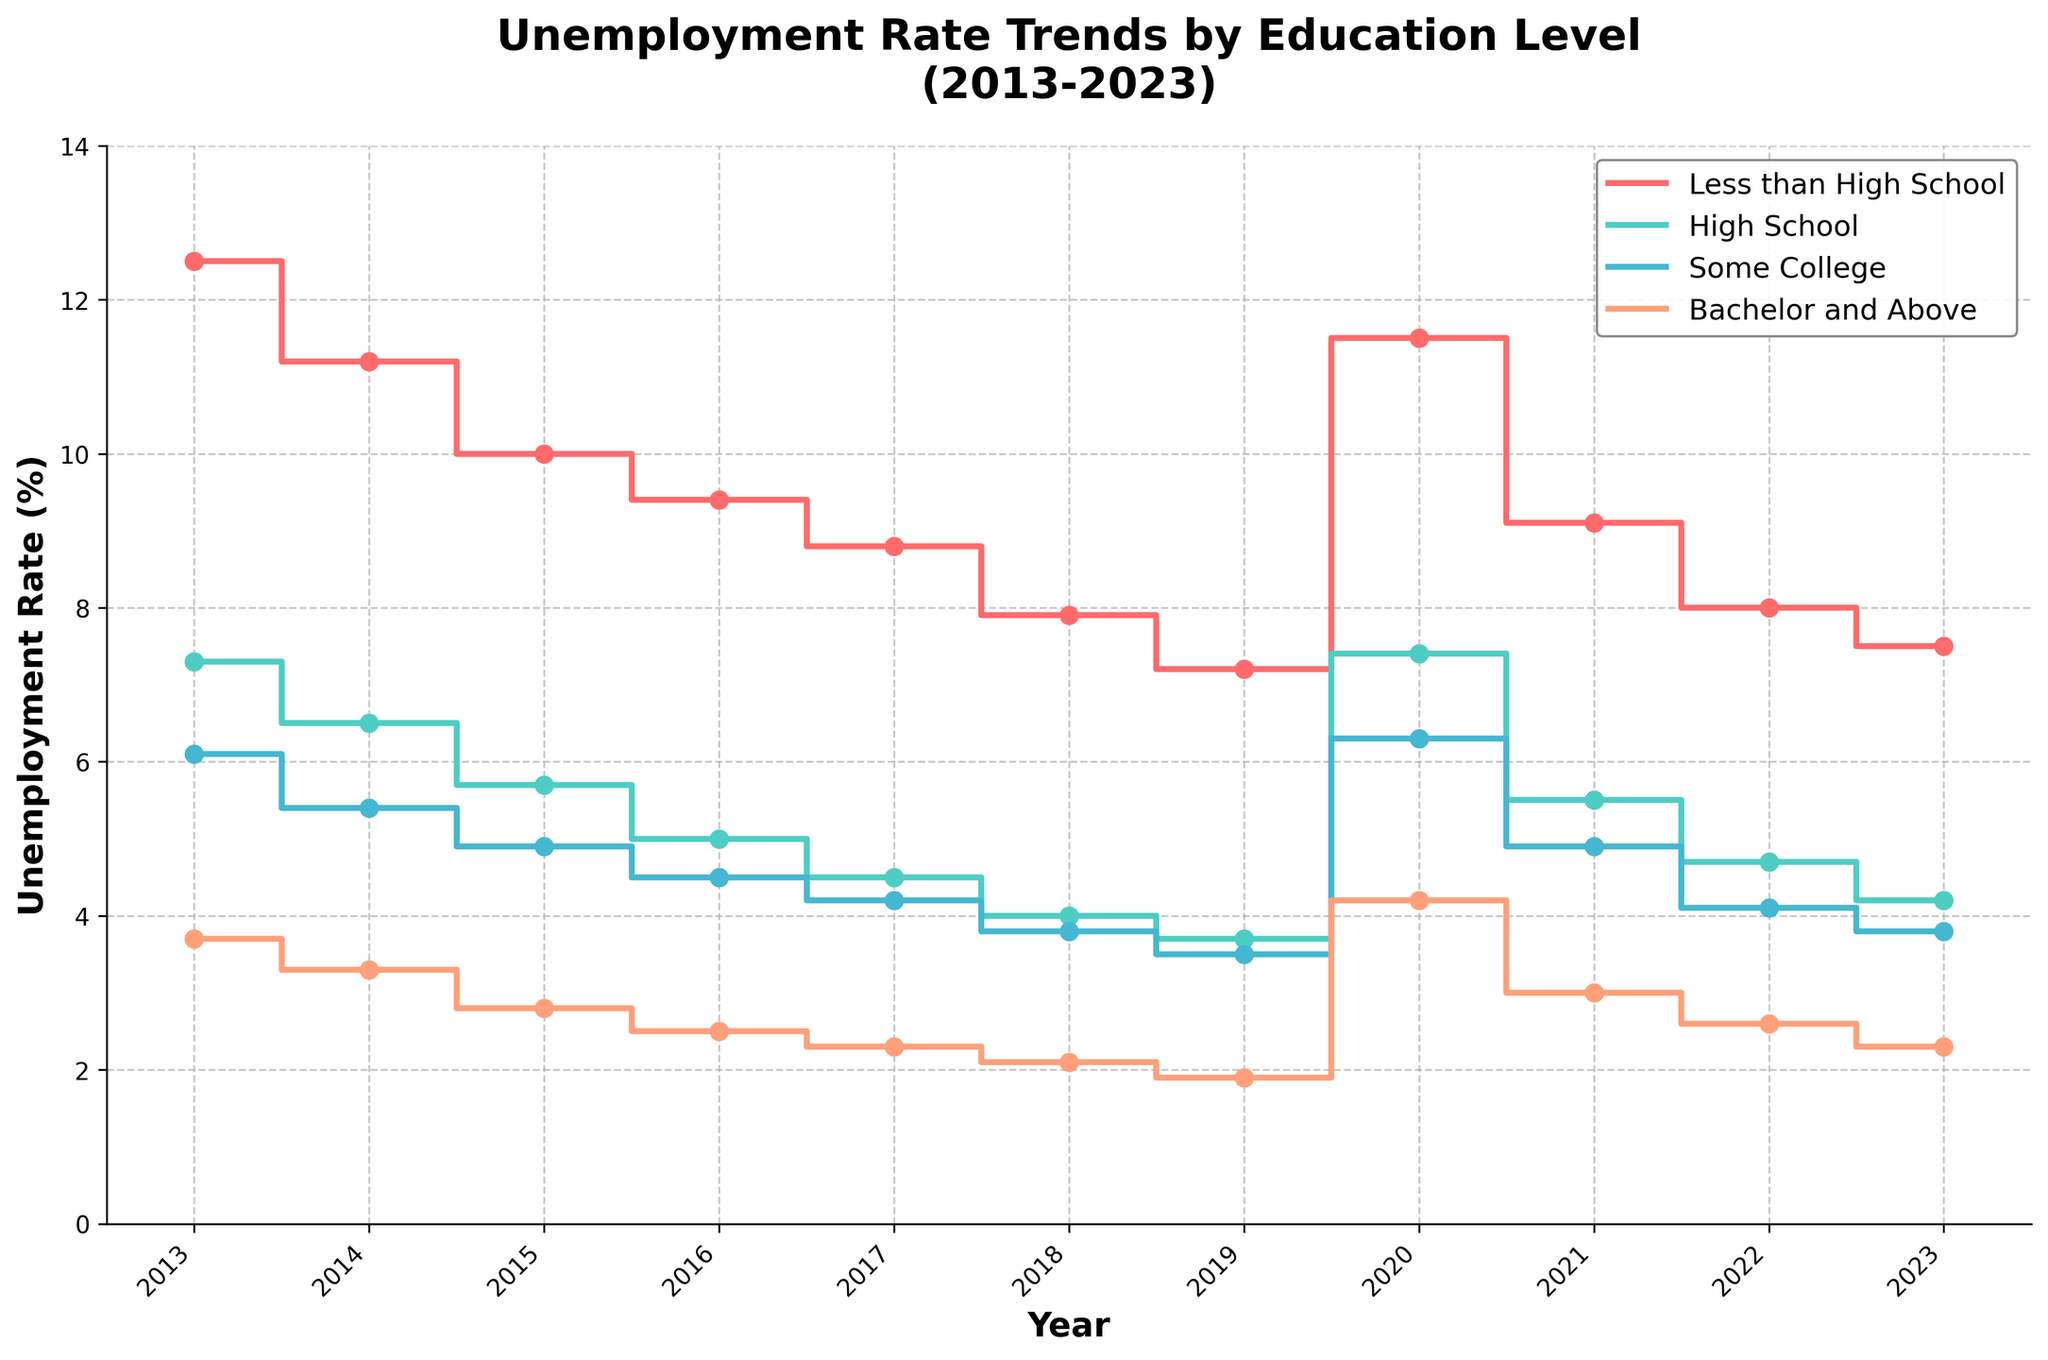How many education levels are displayed in the plot? Observe the legend or the number of lines/labels in the plot. The figure shows four distinct unemployment rate trends corresponding to different education levels.
Answer: 4 What is the general trend in unemployment rates for those with 'Less than High School' education from 2013 to 2023? Observe the 'Less than High School' line, which generally trends downward from 12.5% in 2013 to 7.5% in 2023, indicating a decrease in the unemployment rate over the decade.
Answer: Downward Which year saw the highest unemployment rate for people with 'Bachelor and Above' education? Look for the highest point along the 'Bachelor and Above' line. This occurs in 2020, where the rate is 4.2%.
Answer: 2020 How did the unemployment rate for 'High School' education change between 2019 and 2020? Compare the values for 'High School' in 2019 and 2020. The rate increased from 3.7% in 2019 to 7.4% in 2020.
Answer: Increased What was the unemployment rate for 'Some College' education in 2015 and how does it compare to that in 2023? Identify the rates in 2015 (4.9%) and 2023 (3.8%). It decreased by 1.1 percentage points between these years.
Answer: 4.9% in 2015, 3.8% in 2023, decreased Which education level had the lowest unemployment rate each year? For each year, find the lowest value among the education categories. Each year, the 'Bachelor and Above' category consistently had the lowest unemployment rates.
Answer: Bachelor and Above Did the unemployment rate for 'High School' and 'Less than High School' converge at any point? Examine both lines for points where their rates are close or meet. The closest convergence was in 2020, with 'Less than High School' at 11.5% and 'High School' at 7.4%.
Answer: No, but closest in 2020 By how many percentage points did the unemployment rate for 'Some College' change from its peak year to 2023? The peak for 'Some College' is in 2020 (6.3%), and it was 3.8% in 2023. This is a drop of 6.3 - 3.8 = 2.5 percentage points.
Answer: 2.5 percentage points In which year was the unemployment rate trend for 'High School' education the same as in 'Less than High School' education two years prior? Identify that in 2015, 'Less than High School' was 10.0%. In 2017, 'High School' was 4.5%. There is no such direct overlap in the data.
Answer: None 